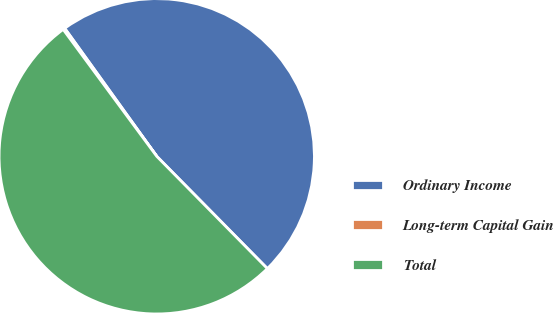Convert chart. <chart><loc_0><loc_0><loc_500><loc_500><pie_chart><fcel>Ordinary Income<fcel>Long-term Capital Gain<fcel>Total<nl><fcel>47.54%<fcel>0.19%<fcel>52.27%<nl></chart> 